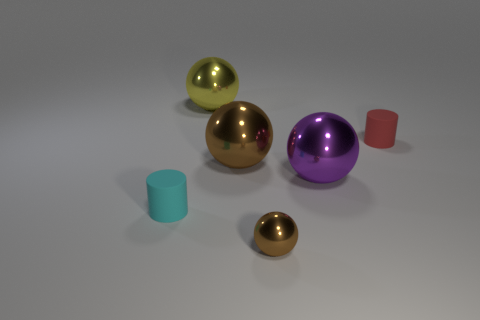There is a matte cylinder that is to the right of the cyan object; what size is it?
Provide a succinct answer. Small. What is the size of the cyan thing?
Offer a terse response. Small. How big is the cylinder on the left side of the small rubber cylinder that is behind the matte cylinder that is left of the red object?
Offer a very short reply. Small. Is there a big yellow object that has the same material as the large brown object?
Make the answer very short. Yes. What is the shape of the small metallic object?
Ensure brevity in your answer.  Sphere. What is the color of the other cylinder that is made of the same material as the small red cylinder?
Make the answer very short. Cyan. What number of brown things are either small spheres or small cylinders?
Provide a succinct answer. 1. Is the number of small cyan objects greater than the number of tiny matte objects?
Ensure brevity in your answer.  No. How many objects are matte cylinders left of the big yellow metal sphere or tiny cylinders behind the purple thing?
Your response must be concise. 2. The other rubber cylinder that is the same size as the red matte cylinder is what color?
Provide a short and direct response. Cyan. 